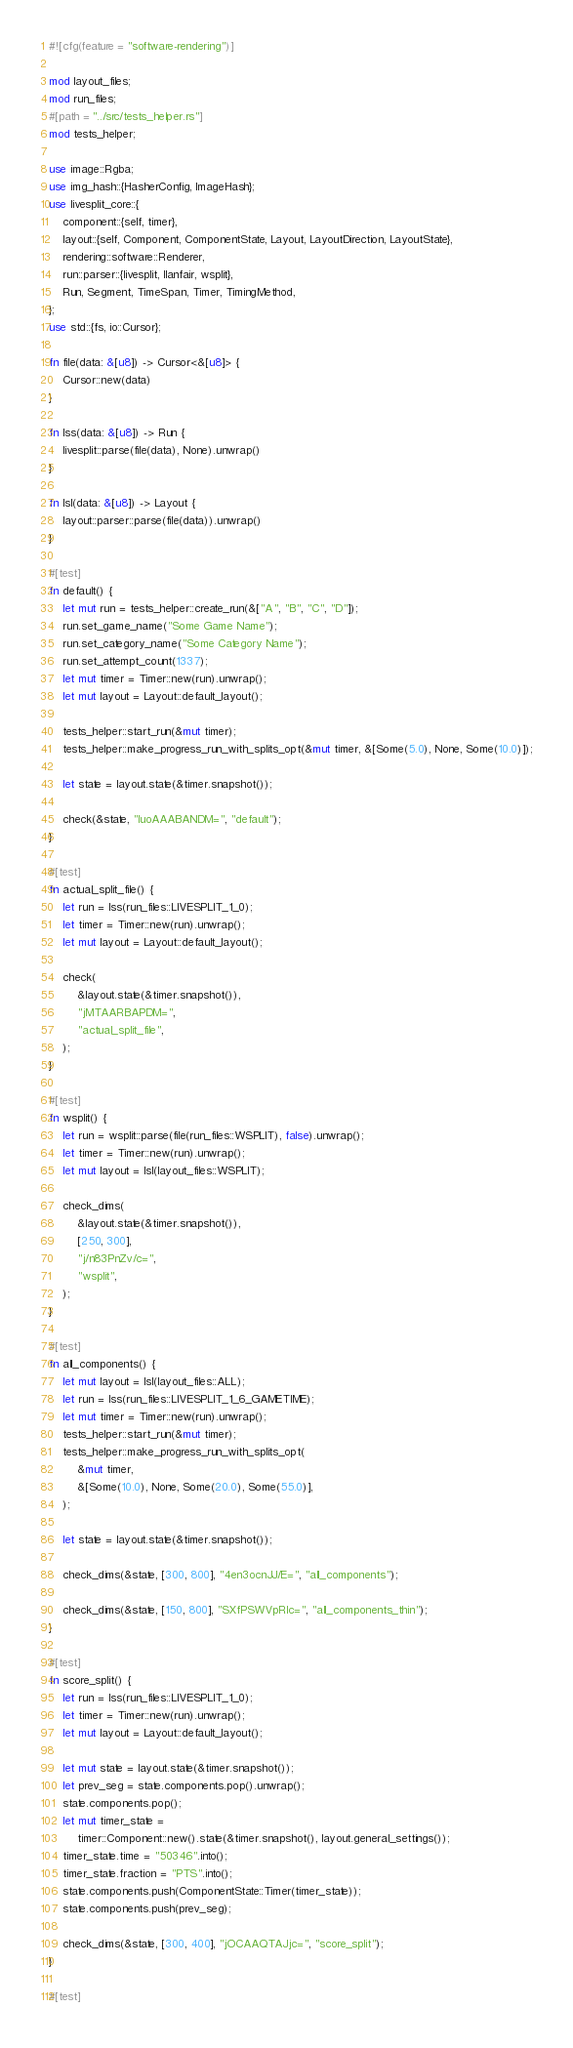<code> <loc_0><loc_0><loc_500><loc_500><_Rust_>#![cfg(feature = "software-rendering")]

mod layout_files;
mod run_files;
#[path = "../src/tests_helper.rs"]
mod tests_helper;

use image::Rgba;
use img_hash::{HasherConfig, ImageHash};
use livesplit_core::{
    component::{self, timer},
    layout::{self, Component, ComponentState, Layout, LayoutDirection, LayoutState},
    rendering::software::Renderer,
    run::parser::{livesplit, llanfair, wsplit},
    Run, Segment, TimeSpan, Timer, TimingMethod,
};
use std::{fs, io::Cursor};

fn file(data: &[u8]) -> Cursor<&[u8]> {
    Cursor::new(data)
}

fn lss(data: &[u8]) -> Run {
    livesplit::parse(file(data), None).unwrap()
}

fn lsl(data: &[u8]) -> Layout {
    layout::parser::parse(file(data)).unwrap()
}

#[test]
fn default() {
    let mut run = tests_helper::create_run(&["A", "B", "C", "D"]);
    run.set_game_name("Some Game Name");
    run.set_category_name("Some Category Name");
    run.set_attempt_count(1337);
    let mut timer = Timer::new(run).unwrap();
    let mut layout = Layout::default_layout();

    tests_helper::start_run(&mut timer);
    tests_helper::make_progress_run_with_splits_opt(&mut timer, &[Some(5.0), None, Some(10.0)]);

    let state = layout.state(&timer.snapshot());

    check(&state, "luoAAABANDM=", "default");
}

#[test]
fn actual_split_file() {
    let run = lss(run_files::LIVESPLIT_1_0);
    let timer = Timer::new(run).unwrap();
    let mut layout = Layout::default_layout();

    check(
        &layout.state(&timer.snapshot()),
        "jMTAARBAPDM=",
        "actual_split_file",
    );
}

#[test]
fn wsplit() {
    let run = wsplit::parse(file(run_files::WSPLIT), false).unwrap();
    let timer = Timer::new(run).unwrap();
    let mut layout = lsl(layout_files::WSPLIT);

    check_dims(
        &layout.state(&timer.snapshot()),
        [250, 300],
        "j/n83PnZv/c=",
        "wsplit",
    );
}

#[test]
fn all_components() {
    let mut layout = lsl(layout_files::ALL);
    let run = lss(run_files::LIVESPLIT_1_6_GAMETIME);
    let mut timer = Timer::new(run).unwrap();
    tests_helper::start_run(&mut timer);
    tests_helper::make_progress_run_with_splits_opt(
        &mut timer,
        &[Some(10.0), None, Some(20.0), Some(55.0)],
    );

    let state = layout.state(&timer.snapshot());

    check_dims(&state, [300, 800], "4en3ocnJJ/E=", "all_components");

    check_dims(&state, [150, 800], "SXfPSWVpRlc=", "all_components_thin");
}

#[test]
fn score_split() {
    let run = lss(run_files::LIVESPLIT_1_0);
    let timer = Timer::new(run).unwrap();
    let mut layout = Layout::default_layout();

    let mut state = layout.state(&timer.snapshot());
    let prev_seg = state.components.pop().unwrap();
    state.components.pop();
    let mut timer_state =
        timer::Component::new().state(&timer.snapshot(), layout.general_settings());
    timer_state.time = "50346".into();
    timer_state.fraction = "PTS".into();
    state.components.push(ComponentState::Timer(timer_state));
    state.components.push(prev_seg);

    check_dims(&state, [300, 400], "jOCAAQTAJjc=", "score_split");
}

#[test]</code> 